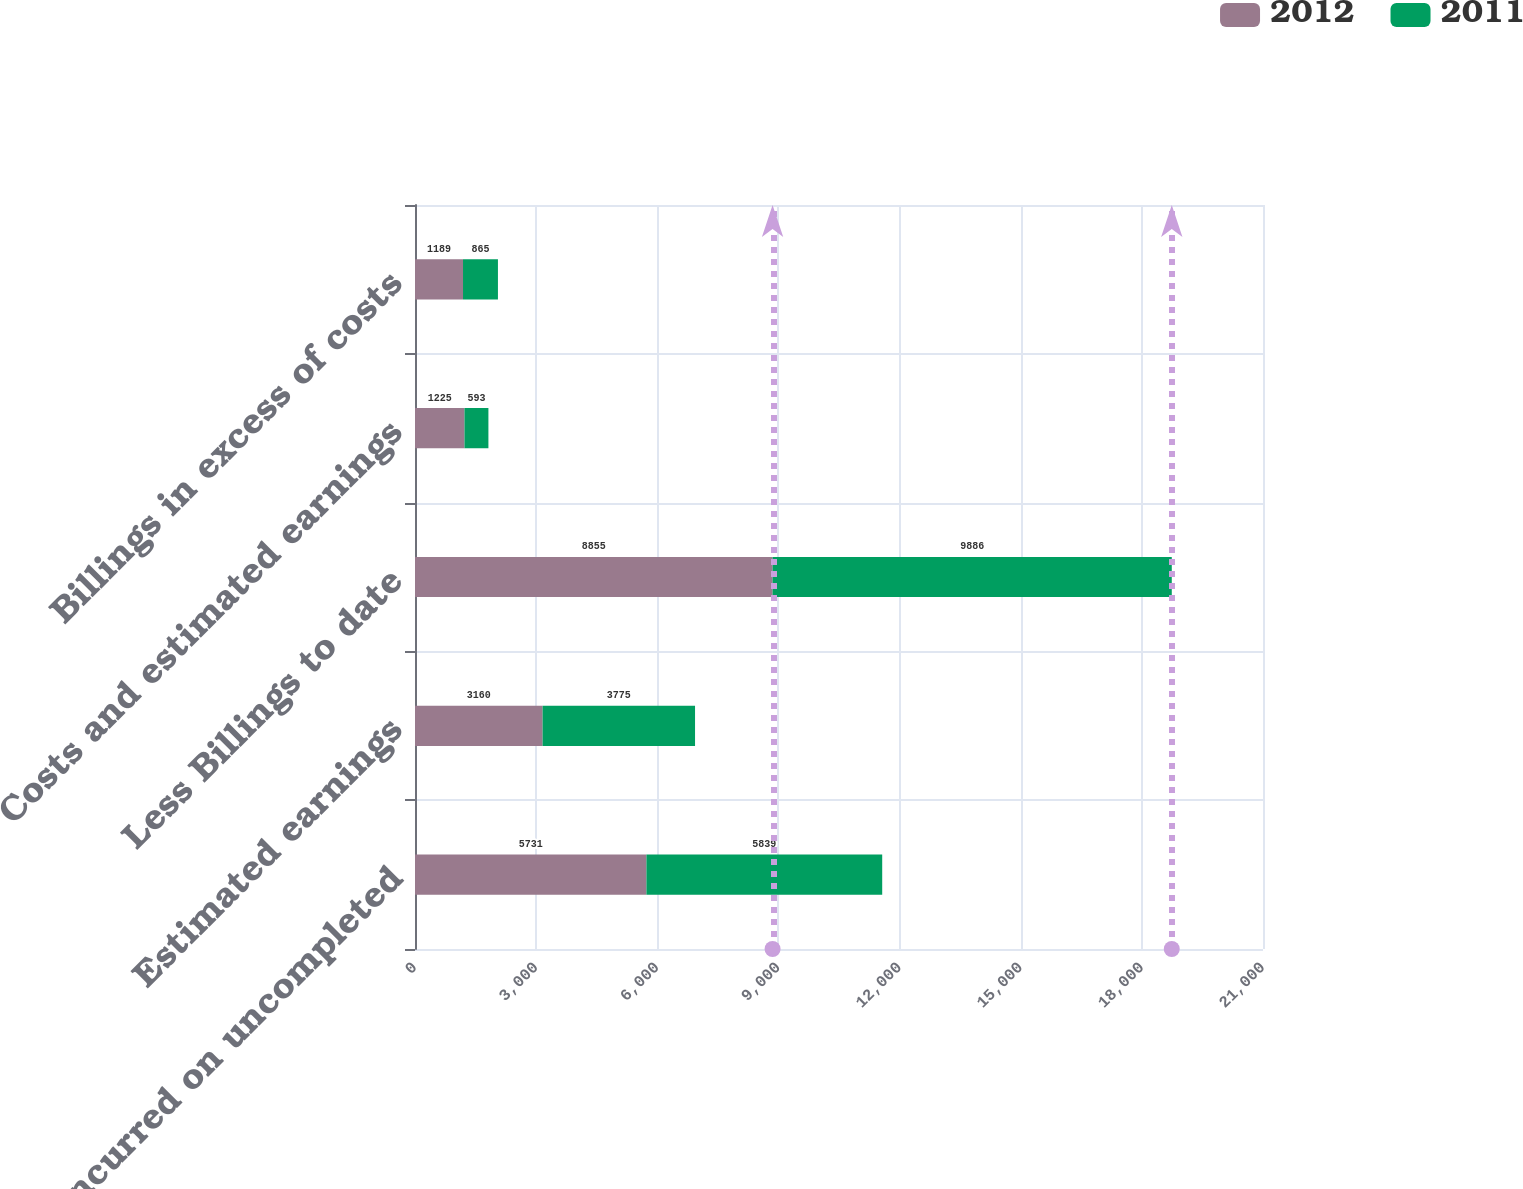Convert chart to OTSL. <chart><loc_0><loc_0><loc_500><loc_500><stacked_bar_chart><ecel><fcel>Costs incurred on uncompleted<fcel>Estimated earnings<fcel>Less Billings to date<fcel>Costs and estimated earnings<fcel>Billings in excess of costs<nl><fcel>2012<fcel>5731<fcel>3160<fcel>8855<fcel>1225<fcel>1189<nl><fcel>2011<fcel>5839<fcel>3775<fcel>9886<fcel>593<fcel>865<nl></chart> 